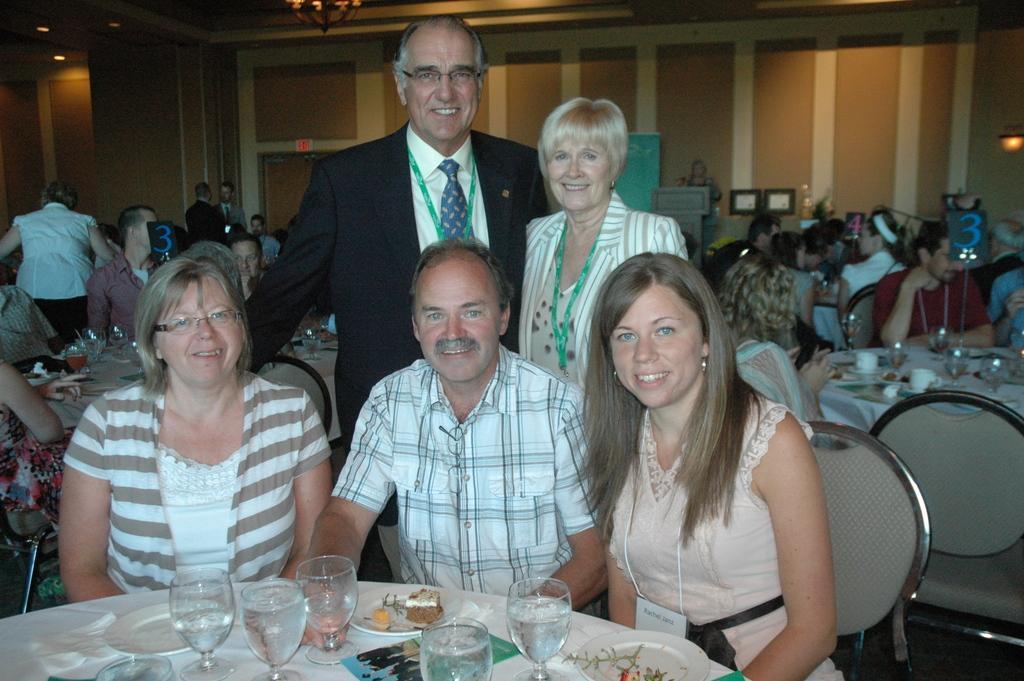Can you describe this image briefly? In this picture there are group of people. In the foreground there are three persons sitting and smiling and there are two persons standing and smiling. At the back there are group of people. There are glasses, plates, tissues on the table and the table is covered with white color cloth. At the back there is a door and there is a wall. At the top there are lights. 